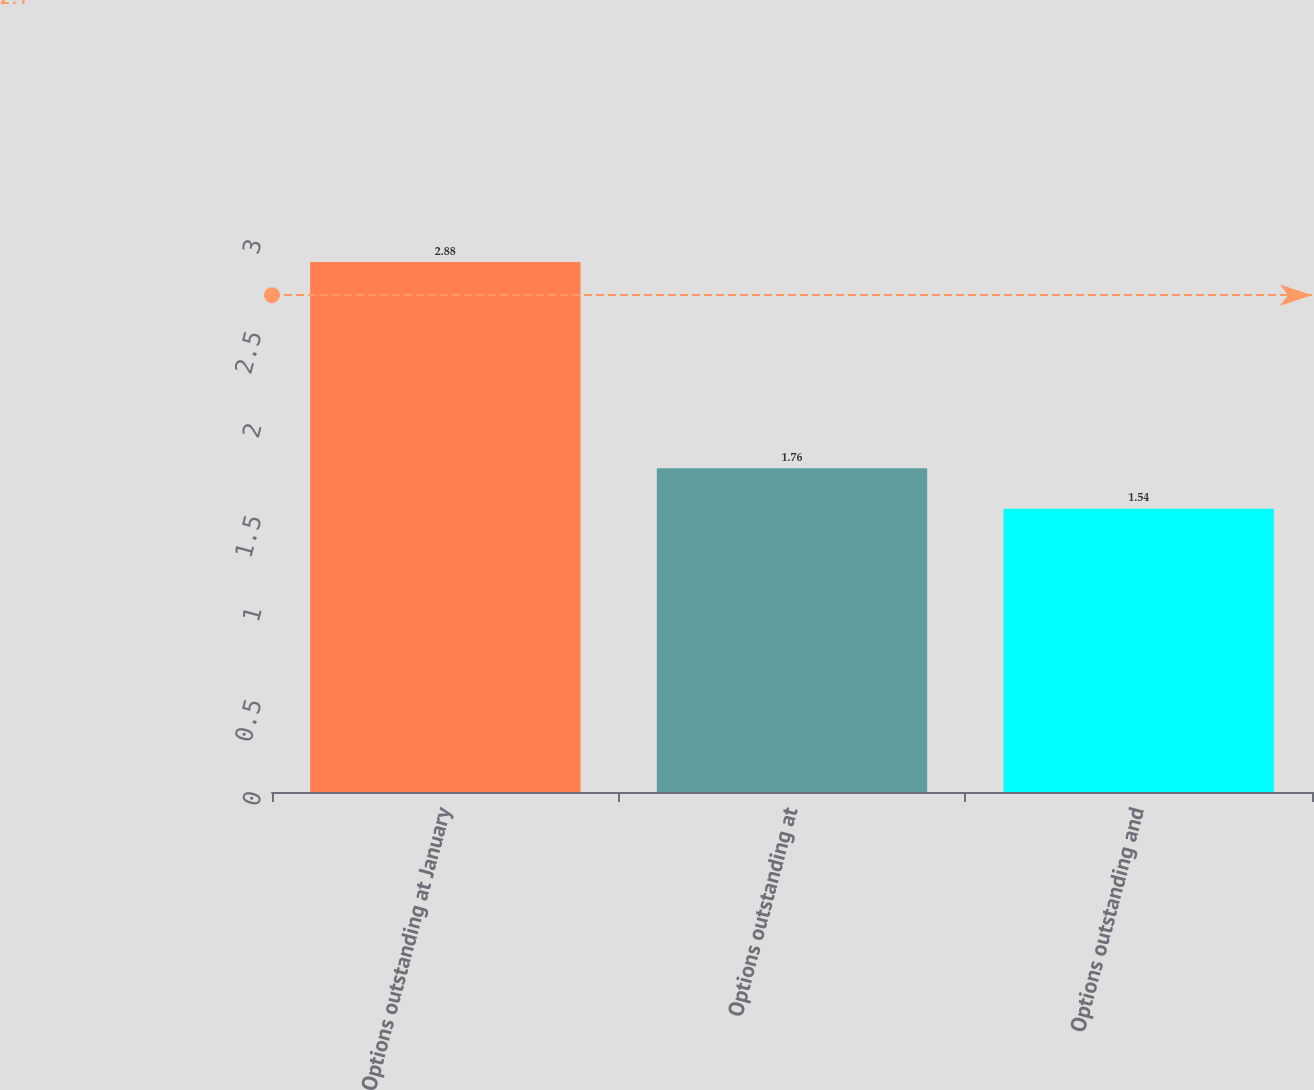Convert chart to OTSL. <chart><loc_0><loc_0><loc_500><loc_500><bar_chart><fcel>Options outstanding at January<fcel>Options outstanding at<fcel>Options outstanding and<nl><fcel>2.88<fcel>1.76<fcel>1.54<nl></chart> 